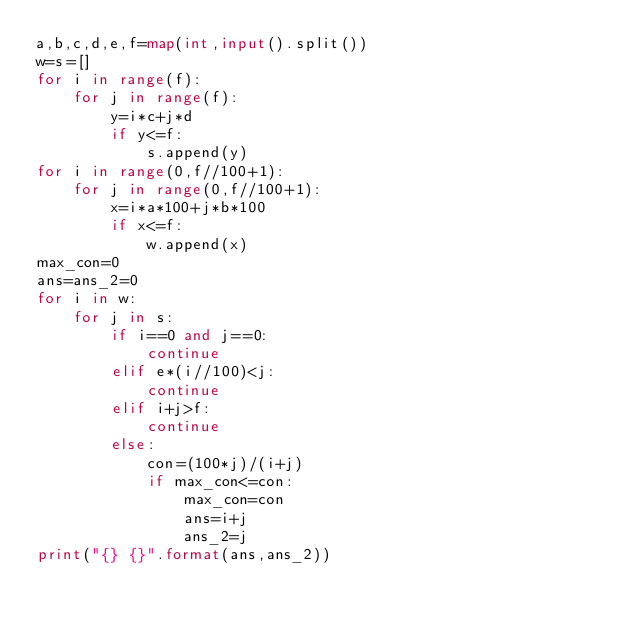<code> <loc_0><loc_0><loc_500><loc_500><_Python_>a,b,c,d,e,f=map(int,input().split())
w=s=[]
for i in range(f):
    for j in range(f):
        y=i*c+j*d
        if y<=f:
            s.append(y)
for i in range(0,f//100+1):
    for j in range(0,f//100+1):
        x=i*a*100+j*b*100
        if x<=f:
            w.append(x)
max_con=0
ans=ans_2=0
for i in w:
    for j in s:
        if i==0 and j==0:
            continue
        elif e*(i//100)<j:
            continue
        elif i+j>f:
            continue
        else:
            con=(100*j)/(i+j)
            if max_con<=con:
                max_con=con
                ans=i+j
                ans_2=j
print("{} {}".format(ans,ans_2))</code> 